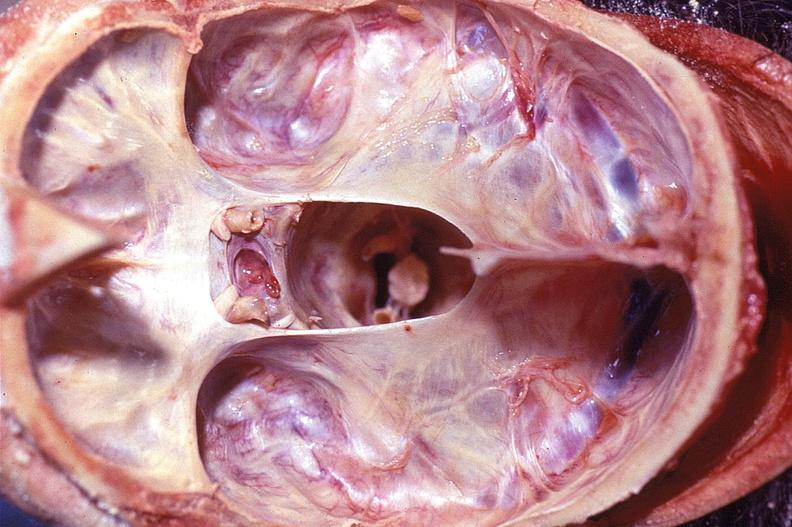does this image show calvarium, sella turcica pituitary gland, normal?
Answer the question using a single word or phrase. Yes 